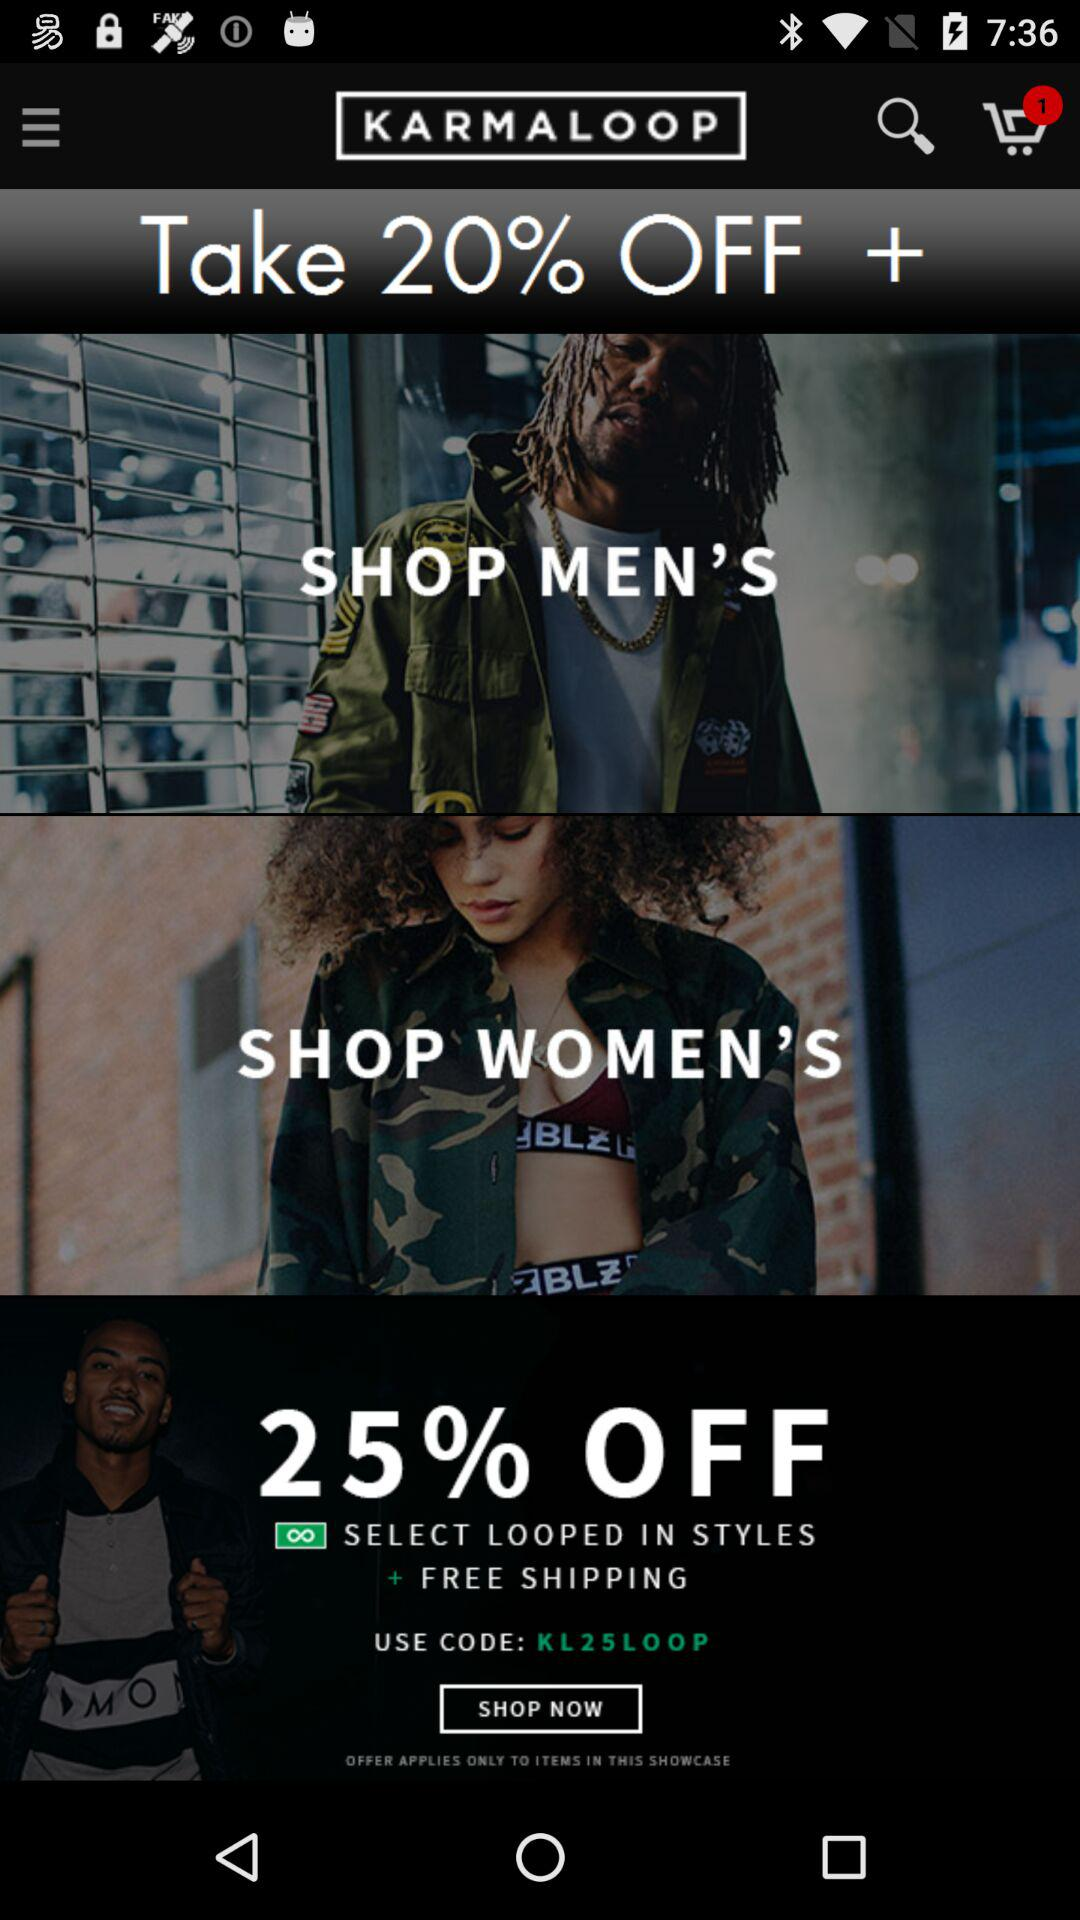What percentage of off is given on the "SELECT LOOPED IN STYLES"? The percentage of off is 25. 